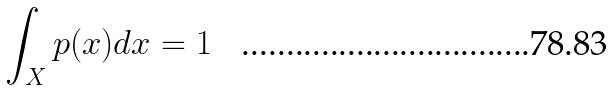<formula> <loc_0><loc_0><loc_500><loc_500>\int _ { X } p ( x ) d x = 1</formula> 